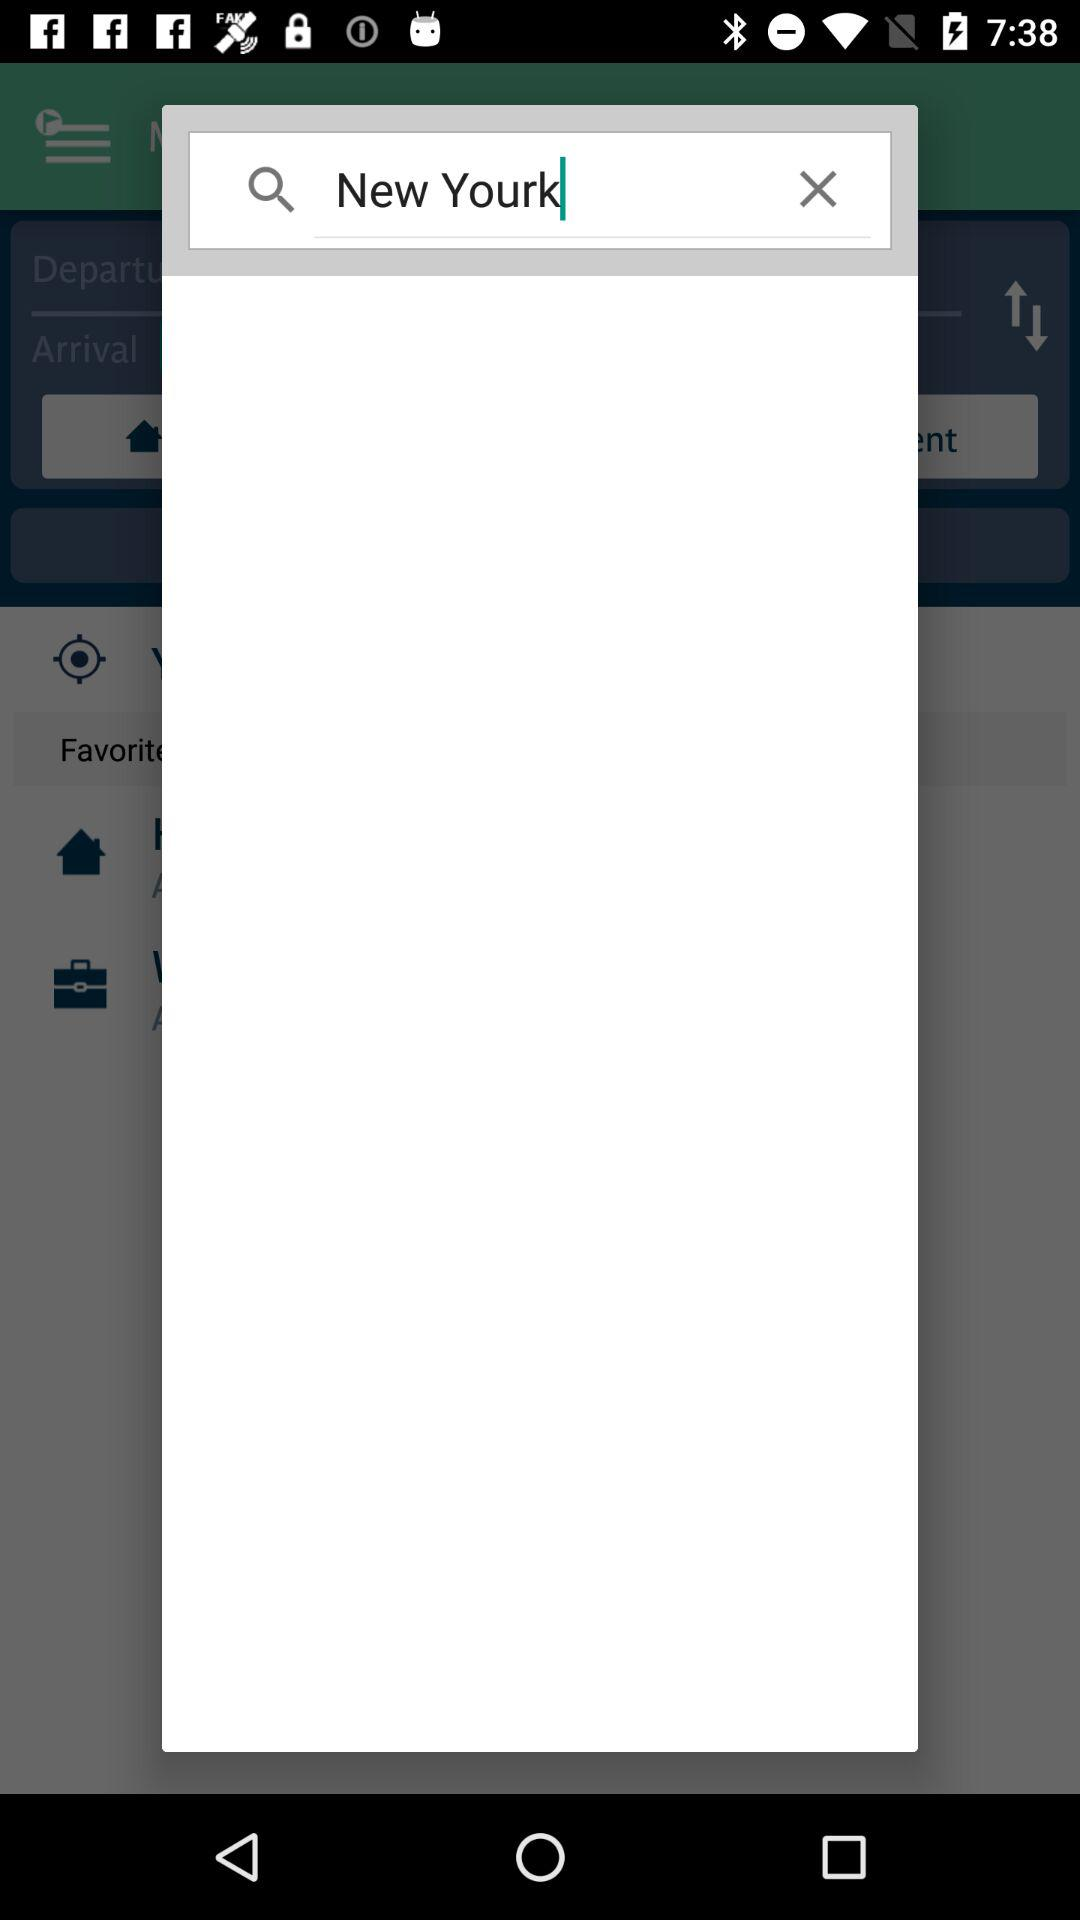What is written in the search box? In the search box, "New Yourk" is written. 